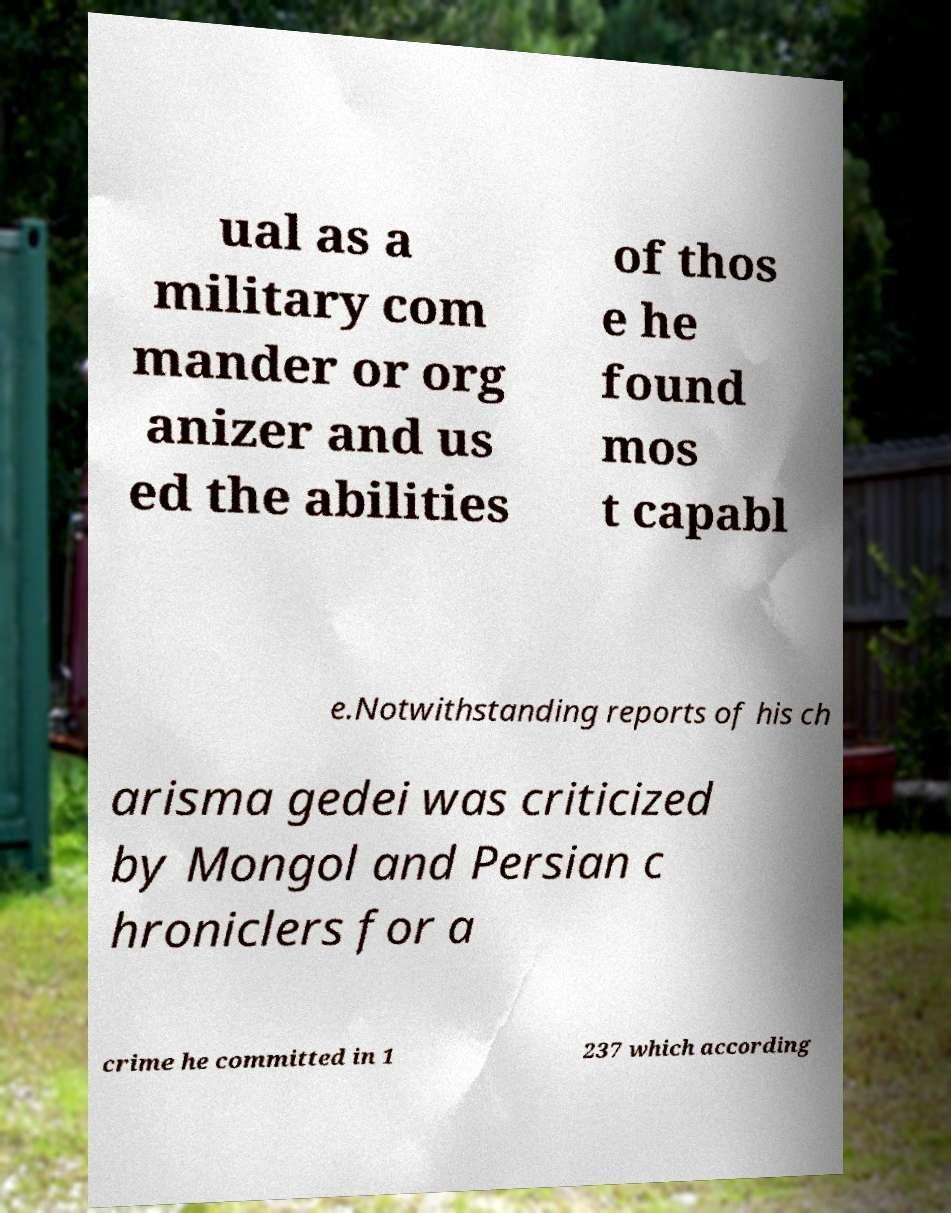I need the written content from this picture converted into text. Can you do that? ual as a military com mander or org anizer and us ed the abilities of thos e he found mos t capabl e.Notwithstanding reports of his ch arisma gedei was criticized by Mongol and Persian c hroniclers for a crime he committed in 1 237 which according 